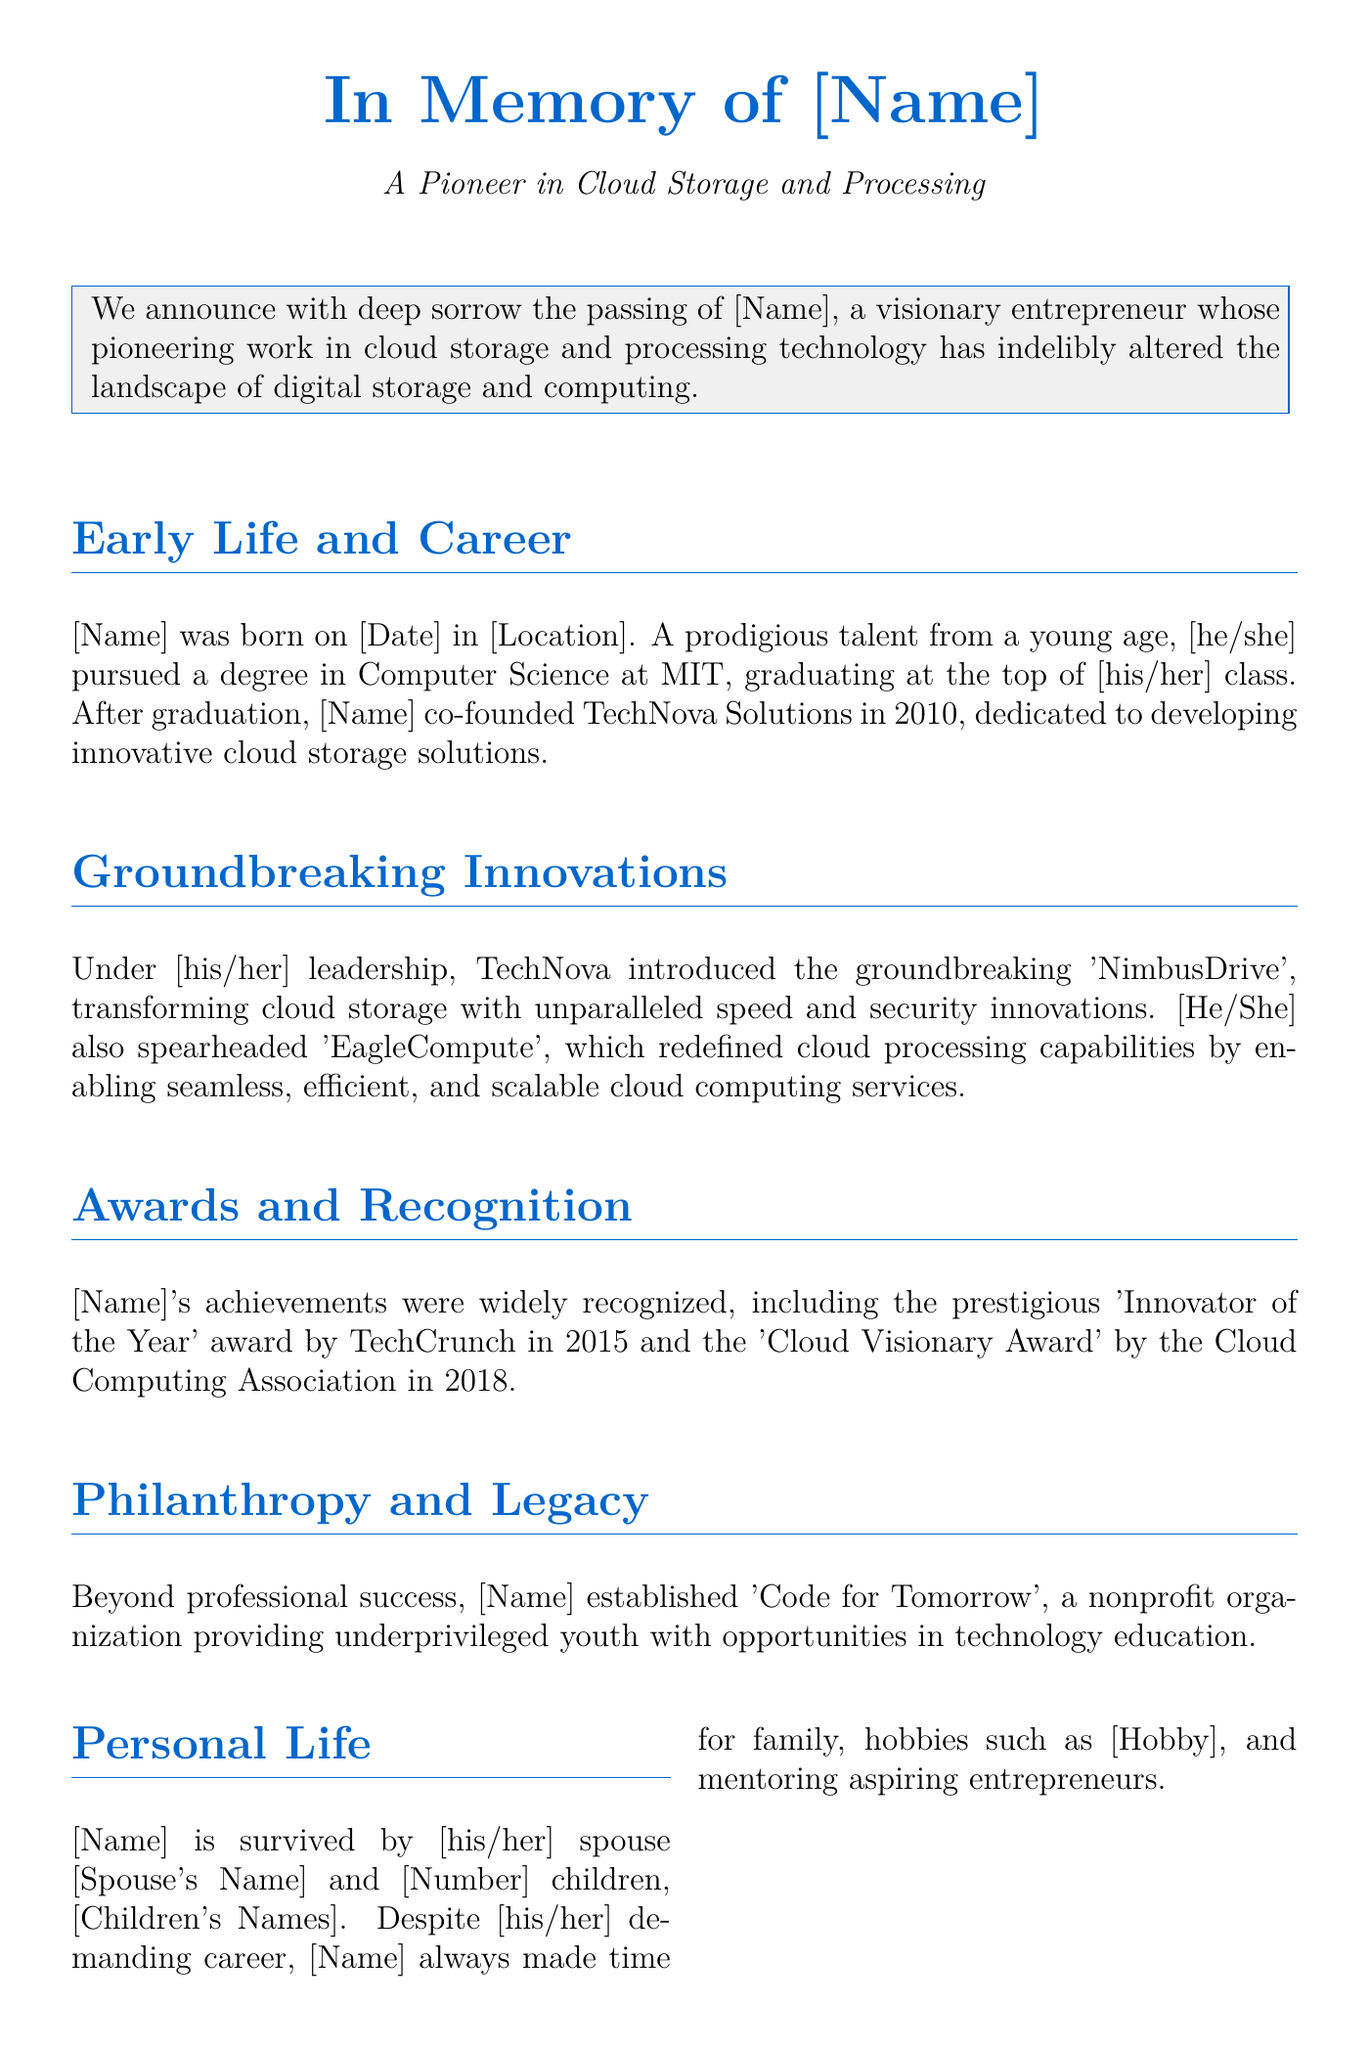What is the name of the entrepreneur? The document refers to the individual as [Name], indicating a placeholder for the actual name.
Answer: [Name] When was [Name] born? The birth date is indicated as [Date], shown as a placeholder in the document.
Answer: [Date] What company did [Name] co-found? The co-founded company is TechNova Solutions, as stated in the document.
Answer: TechNova Solutions What is the name of the innovative cloud storage solution introduced by [Name]? The document mentions 'NimbusDrive' as the transformative cloud storage solution developed under [his/her] leadership.
Answer: NimbusDrive Which award did [Name] receive in 2015? [Name] was honored with the 'Innovator of the Year' award by TechCrunch in 2015.
Answer: Innovator of the Year What nonprofit organization did [Name] establish? According to the document, [Name] established 'Code for Tomorrow' as a nonprofit organization.
Answer: Code for Tomorrow How many children does [Name] have? The document states that [Name] has [Number] children, which is a placeholder for the actual number.
Answer: [Number] What hobby did [Name] enjoy? The document mentions that [Name] had hobbies including [Hobby], which is noted as a placeholder.
Answer: [Hobby] What was a notable impact of [Name]'s work? The document describes [Name]'s work as having left an indelible mark on the industry and future of digital storage and computing.
Answer: Indelible mark on the industry and future of digital storage and computing 